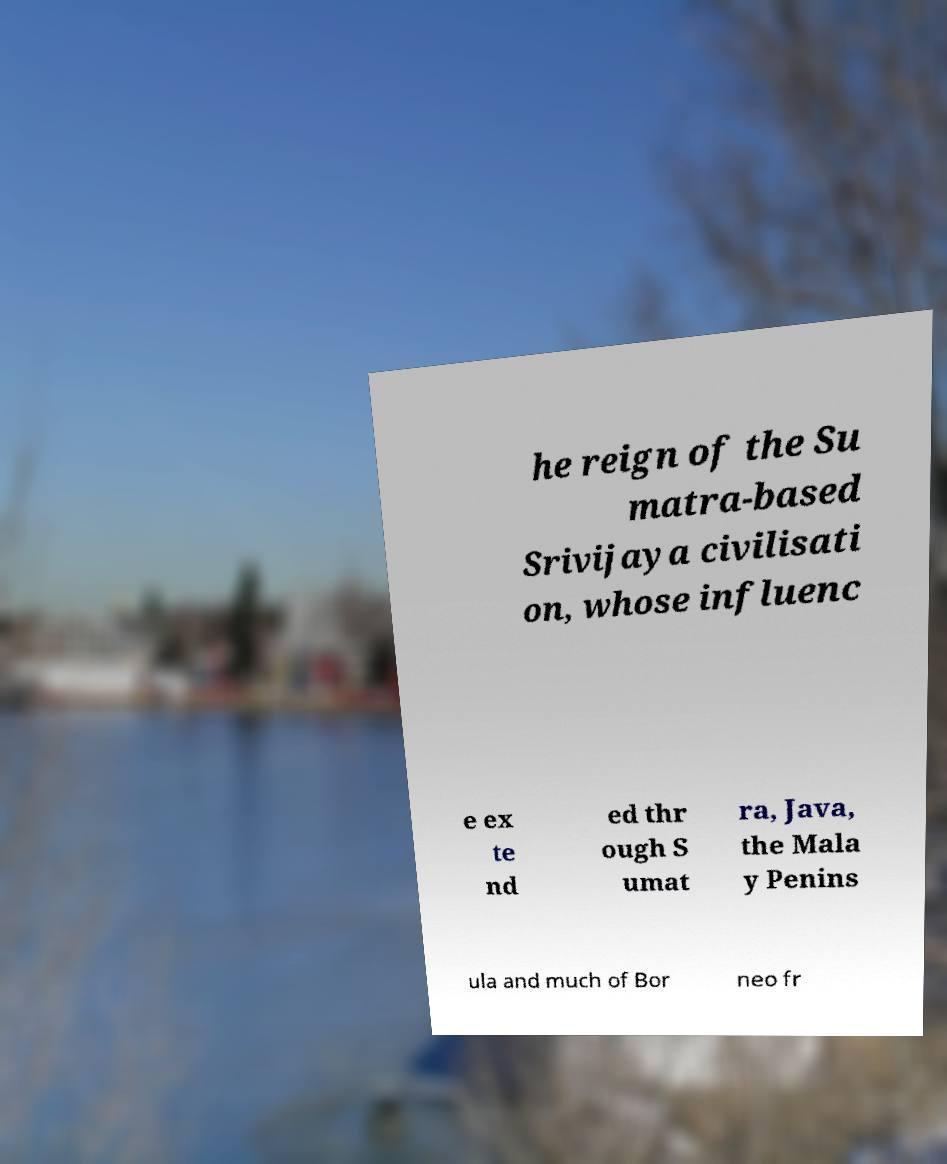Please read and relay the text visible in this image. What does it say? he reign of the Su matra-based Srivijaya civilisati on, whose influenc e ex te nd ed thr ough S umat ra, Java, the Mala y Penins ula and much of Bor neo fr 